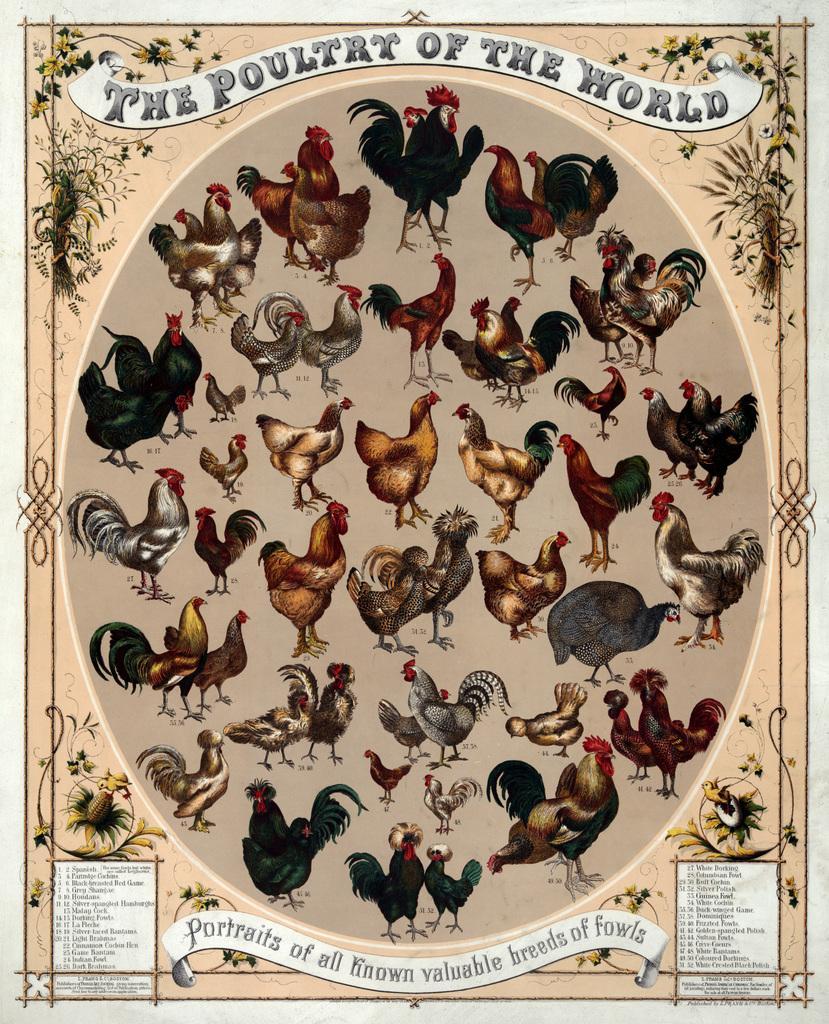Describe this image in one or two sentences. This image consists of a poster in which there are pictures of the hens. 